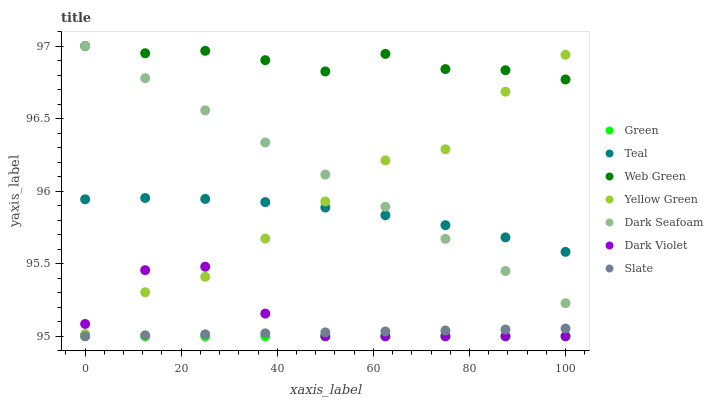Does Green have the minimum area under the curve?
Answer yes or no. Yes. Does Web Green have the maximum area under the curve?
Answer yes or no. Yes. Does Slate have the minimum area under the curve?
Answer yes or no. No. Does Slate have the maximum area under the curve?
Answer yes or no. No. Is Green the smoothest?
Answer yes or no. Yes. Is Yellow Green the roughest?
Answer yes or no. Yes. Is Slate the smoothest?
Answer yes or no. No. Is Slate the roughest?
Answer yes or no. No. Does Slate have the lowest value?
Answer yes or no. Yes. Does Dark Seafoam have the lowest value?
Answer yes or no. No. Does Web Green have the highest value?
Answer yes or no. Yes. Does Slate have the highest value?
Answer yes or no. No. Is Green less than Dark Seafoam?
Answer yes or no. Yes. Is Teal greater than Dark Violet?
Answer yes or no. Yes. Does Web Green intersect Yellow Green?
Answer yes or no. Yes. Is Web Green less than Yellow Green?
Answer yes or no. No. Is Web Green greater than Yellow Green?
Answer yes or no. No. Does Green intersect Dark Seafoam?
Answer yes or no. No. 